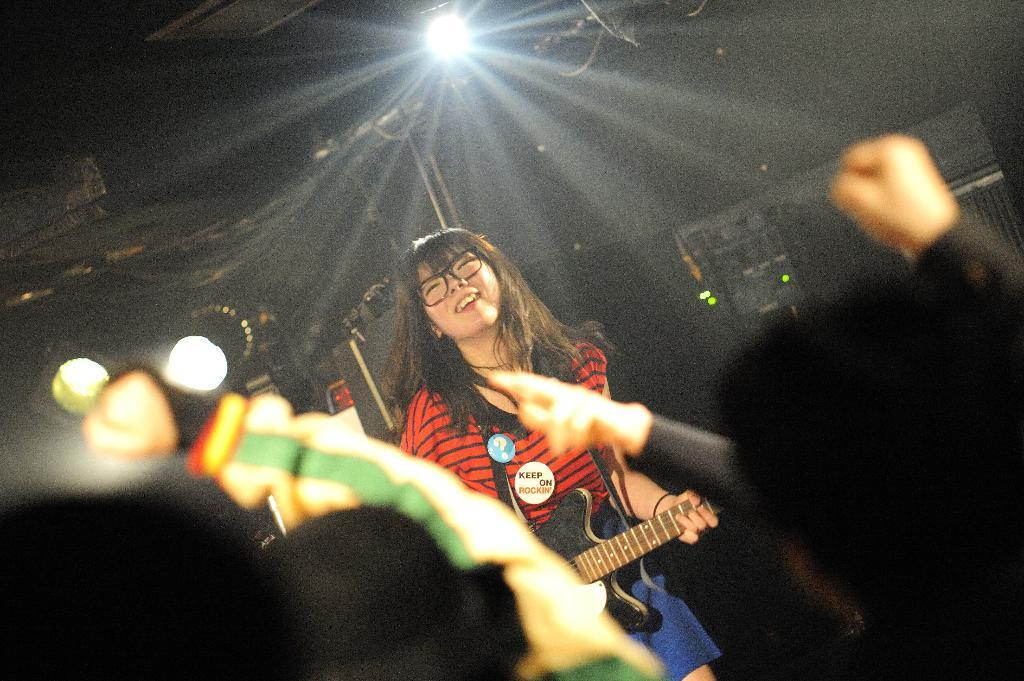Who is the main subject in the image? There is a man in the image. What is the man doing in the image? The man is standing and holding a guitar. Are there any other people in the image? Yes, there are people standing in front of the man. What can be seen in the background of the image? Light is visible in the image. What type of plant is growing out of the man's mouth in the image? There is no plant growing out of the man's mouth in the image; he is holding a guitar and standing with other people. Can you describe the jellyfish that is swimming near the man in the image? There are no jellyfish present in the image; it features a man holding a guitar and standing with other people. 